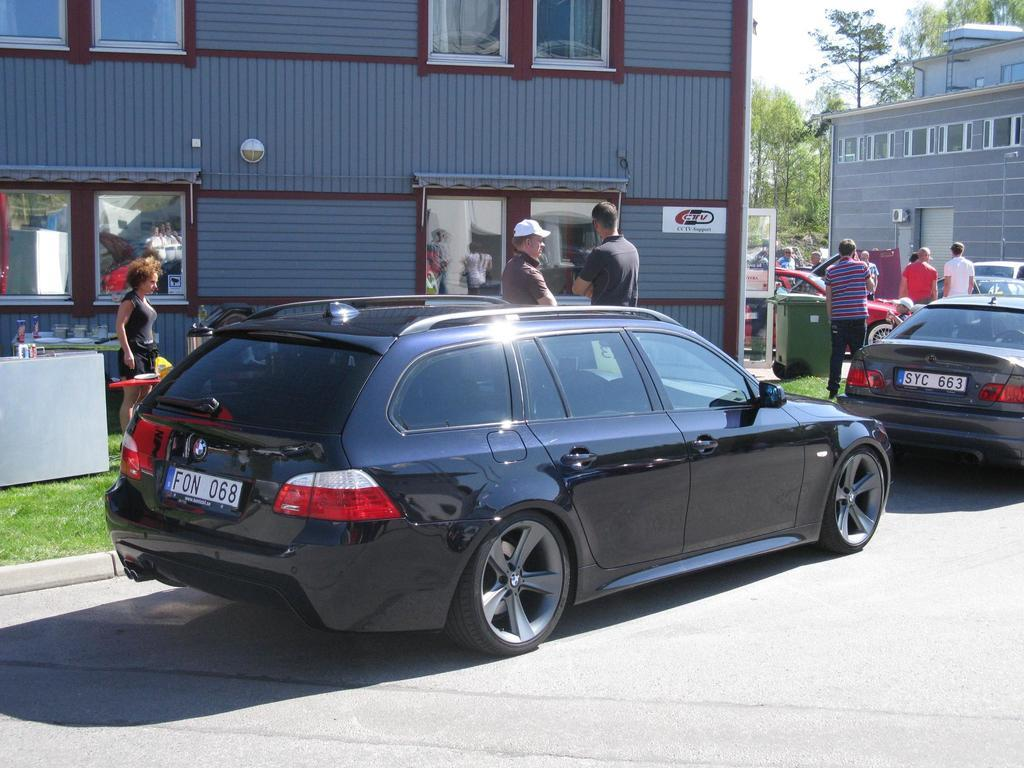<image>
Write a terse but informative summary of the picture. a license plate that has the letters FON on it 